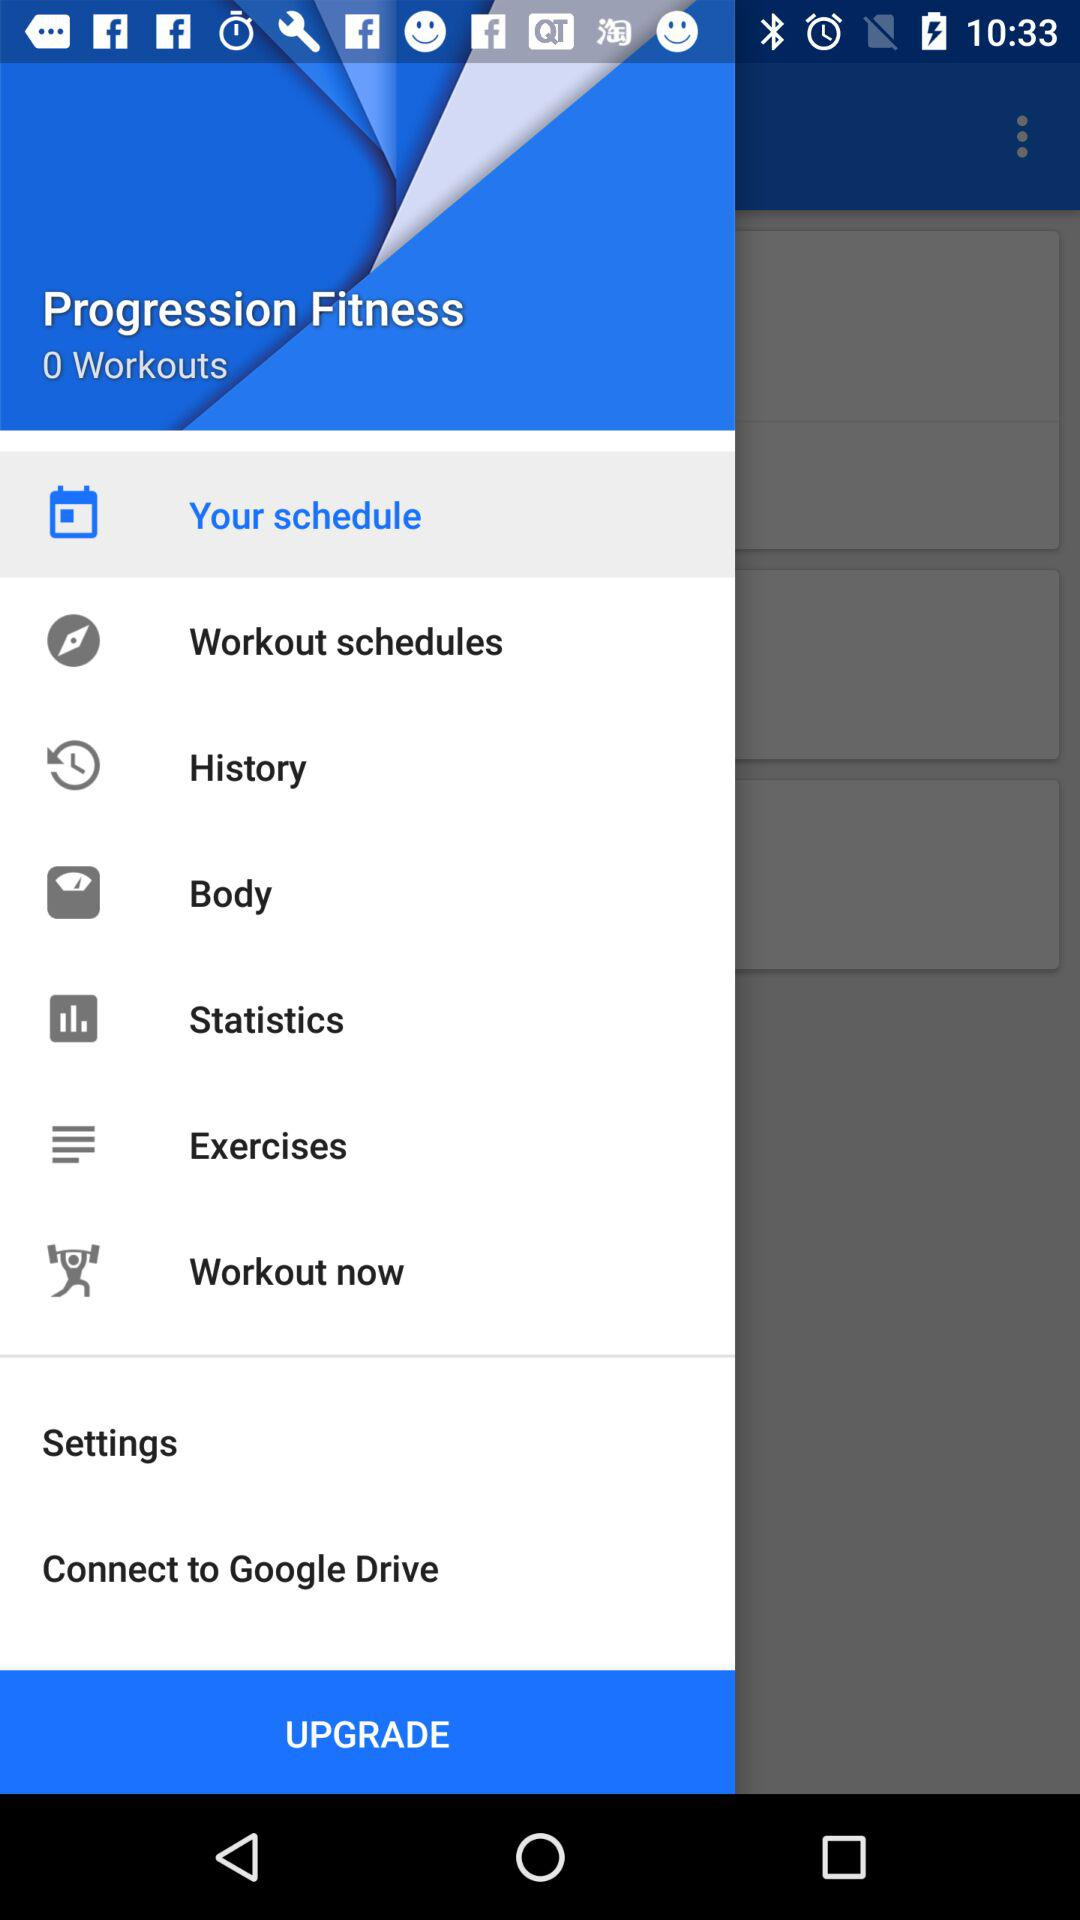What is the number of workouts? The number of workouts is 0. 